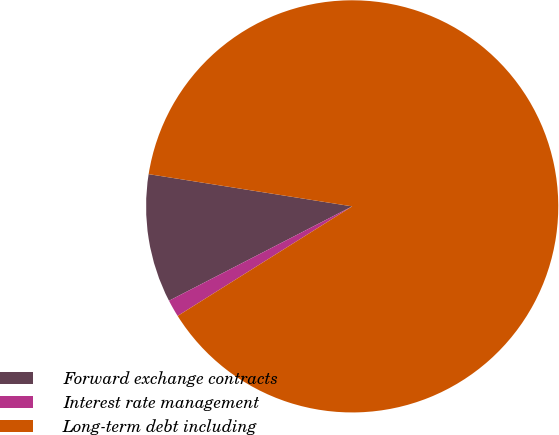<chart> <loc_0><loc_0><loc_500><loc_500><pie_chart><fcel>Forward exchange contracts<fcel>Interest rate management<fcel>Long-term debt including<nl><fcel>10.07%<fcel>1.35%<fcel>88.57%<nl></chart> 